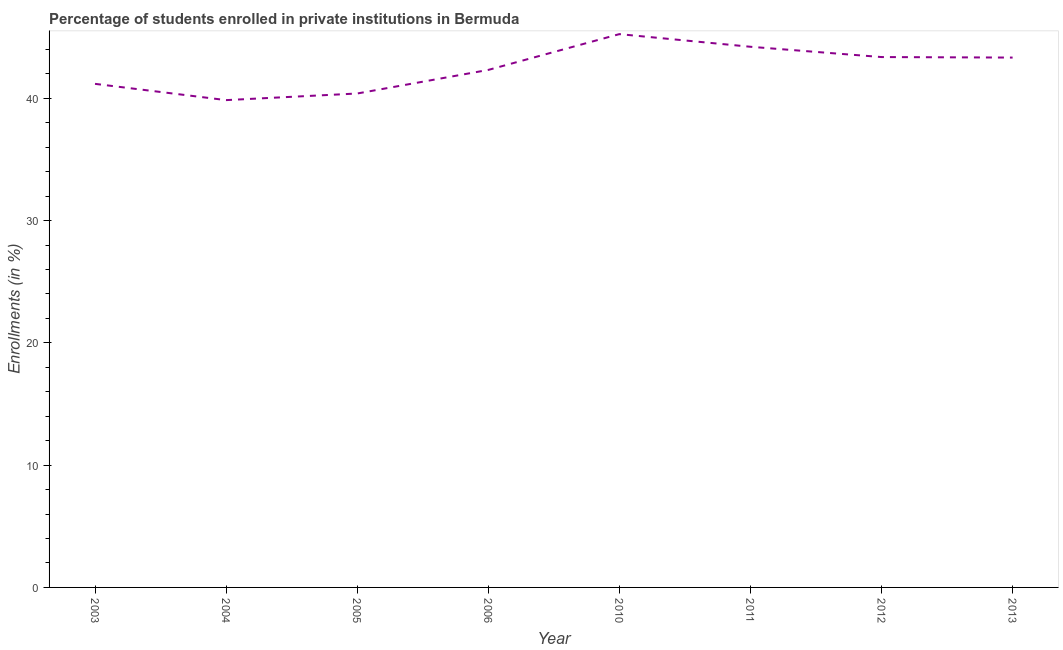What is the enrollments in private institutions in 2006?
Give a very brief answer. 42.32. Across all years, what is the maximum enrollments in private institutions?
Keep it short and to the point. 45.25. Across all years, what is the minimum enrollments in private institutions?
Provide a succinct answer. 39.85. In which year was the enrollments in private institutions maximum?
Offer a very short reply. 2010. What is the sum of the enrollments in private institutions?
Offer a terse response. 339.9. What is the difference between the enrollments in private institutions in 2005 and 2011?
Provide a short and direct response. -3.82. What is the average enrollments in private institutions per year?
Make the answer very short. 42.49. What is the median enrollments in private institutions?
Your answer should be compact. 42.82. What is the ratio of the enrollments in private institutions in 2005 to that in 2012?
Give a very brief answer. 0.93. Is the difference between the enrollments in private institutions in 2003 and 2013 greater than the difference between any two years?
Keep it short and to the point. No. What is the difference between the highest and the second highest enrollments in private institutions?
Your answer should be compact. 1.03. What is the difference between the highest and the lowest enrollments in private institutions?
Offer a very short reply. 5.4. Does the enrollments in private institutions monotonically increase over the years?
Offer a terse response. No. How many lines are there?
Offer a terse response. 1. How many years are there in the graph?
Make the answer very short. 8. Does the graph contain any zero values?
Make the answer very short. No. Does the graph contain grids?
Offer a terse response. No. What is the title of the graph?
Make the answer very short. Percentage of students enrolled in private institutions in Bermuda. What is the label or title of the X-axis?
Keep it short and to the point. Year. What is the label or title of the Y-axis?
Your response must be concise. Enrollments (in %). What is the Enrollments (in %) of 2003?
Your answer should be compact. 41.18. What is the Enrollments (in %) in 2004?
Offer a terse response. 39.85. What is the Enrollments (in %) in 2005?
Keep it short and to the point. 40.39. What is the Enrollments (in %) in 2006?
Offer a very short reply. 42.32. What is the Enrollments (in %) in 2010?
Make the answer very short. 45.25. What is the Enrollments (in %) in 2011?
Make the answer very short. 44.21. What is the Enrollments (in %) in 2012?
Keep it short and to the point. 43.37. What is the Enrollments (in %) in 2013?
Make the answer very short. 43.33. What is the difference between the Enrollments (in %) in 2003 and 2004?
Your response must be concise. 1.33. What is the difference between the Enrollments (in %) in 2003 and 2005?
Make the answer very short. 0.79. What is the difference between the Enrollments (in %) in 2003 and 2006?
Your answer should be very brief. -1.14. What is the difference between the Enrollments (in %) in 2003 and 2010?
Offer a very short reply. -4.07. What is the difference between the Enrollments (in %) in 2003 and 2011?
Make the answer very short. -3.03. What is the difference between the Enrollments (in %) in 2003 and 2012?
Give a very brief answer. -2.19. What is the difference between the Enrollments (in %) in 2003 and 2013?
Ensure brevity in your answer.  -2.15. What is the difference between the Enrollments (in %) in 2004 and 2005?
Ensure brevity in your answer.  -0.54. What is the difference between the Enrollments (in %) in 2004 and 2006?
Offer a terse response. -2.47. What is the difference between the Enrollments (in %) in 2004 and 2010?
Provide a short and direct response. -5.4. What is the difference between the Enrollments (in %) in 2004 and 2011?
Your answer should be very brief. -4.36. What is the difference between the Enrollments (in %) in 2004 and 2012?
Provide a succinct answer. -3.52. What is the difference between the Enrollments (in %) in 2004 and 2013?
Make the answer very short. -3.48. What is the difference between the Enrollments (in %) in 2005 and 2006?
Your answer should be very brief. -1.93. What is the difference between the Enrollments (in %) in 2005 and 2010?
Offer a terse response. -4.86. What is the difference between the Enrollments (in %) in 2005 and 2011?
Keep it short and to the point. -3.82. What is the difference between the Enrollments (in %) in 2005 and 2012?
Offer a very short reply. -2.98. What is the difference between the Enrollments (in %) in 2005 and 2013?
Make the answer very short. -2.94. What is the difference between the Enrollments (in %) in 2006 and 2010?
Your response must be concise. -2.93. What is the difference between the Enrollments (in %) in 2006 and 2011?
Make the answer very short. -1.89. What is the difference between the Enrollments (in %) in 2006 and 2012?
Your response must be concise. -1.05. What is the difference between the Enrollments (in %) in 2006 and 2013?
Keep it short and to the point. -1.01. What is the difference between the Enrollments (in %) in 2010 and 2011?
Provide a short and direct response. 1.03. What is the difference between the Enrollments (in %) in 2010 and 2012?
Your answer should be compact. 1.88. What is the difference between the Enrollments (in %) in 2010 and 2013?
Your response must be concise. 1.92. What is the difference between the Enrollments (in %) in 2011 and 2012?
Keep it short and to the point. 0.84. What is the difference between the Enrollments (in %) in 2011 and 2013?
Offer a terse response. 0.88. What is the difference between the Enrollments (in %) in 2012 and 2013?
Your answer should be very brief. 0.04. What is the ratio of the Enrollments (in %) in 2003 to that in 2004?
Ensure brevity in your answer.  1.03. What is the ratio of the Enrollments (in %) in 2003 to that in 2005?
Your response must be concise. 1.02. What is the ratio of the Enrollments (in %) in 2003 to that in 2006?
Provide a succinct answer. 0.97. What is the ratio of the Enrollments (in %) in 2003 to that in 2010?
Keep it short and to the point. 0.91. What is the ratio of the Enrollments (in %) in 2003 to that in 2012?
Offer a terse response. 0.95. What is the ratio of the Enrollments (in %) in 2003 to that in 2013?
Provide a short and direct response. 0.95. What is the ratio of the Enrollments (in %) in 2004 to that in 2005?
Give a very brief answer. 0.99. What is the ratio of the Enrollments (in %) in 2004 to that in 2006?
Your answer should be compact. 0.94. What is the ratio of the Enrollments (in %) in 2004 to that in 2010?
Offer a very short reply. 0.88. What is the ratio of the Enrollments (in %) in 2004 to that in 2011?
Keep it short and to the point. 0.9. What is the ratio of the Enrollments (in %) in 2004 to that in 2012?
Your answer should be very brief. 0.92. What is the ratio of the Enrollments (in %) in 2005 to that in 2006?
Offer a terse response. 0.95. What is the ratio of the Enrollments (in %) in 2005 to that in 2010?
Keep it short and to the point. 0.89. What is the ratio of the Enrollments (in %) in 2005 to that in 2011?
Give a very brief answer. 0.91. What is the ratio of the Enrollments (in %) in 2005 to that in 2013?
Your answer should be compact. 0.93. What is the ratio of the Enrollments (in %) in 2006 to that in 2010?
Provide a short and direct response. 0.94. What is the ratio of the Enrollments (in %) in 2006 to that in 2013?
Provide a succinct answer. 0.98. What is the ratio of the Enrollments (in %) in 2010 to that in 2011?
Your response must be concise. 1.02. What is the ratio of the Enrollments (in %) in 2010 to that in 2012?
Your answer should be compact. 1.04. What is the ratio of the Enrollments (in %) in 2010 to that in 2013?
Make the answer very short. 1.04. What is the ratio of the Enrollments (in %) in 2011 to that in 2012?
Give a very brief answer. 1.02. What is the ratio of the Enrollments (in %) in 2011 to that in 2013?
Provide a short and direct response. 1.02. 